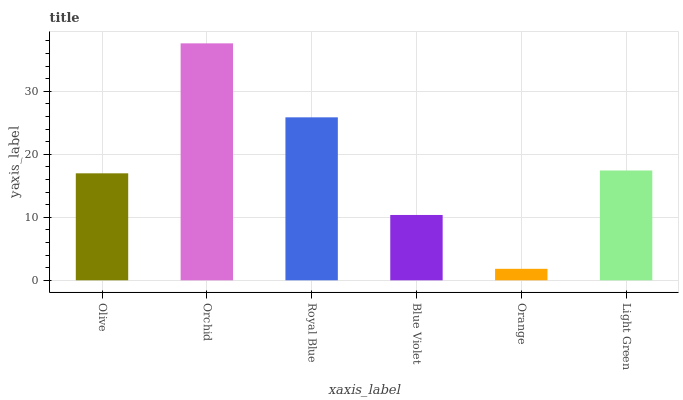Is Orange the minimum?
Answer yes or no. Yes. Is Orchid the maximum?
Answer yes or no. Yes. Is Royal Blue the minimum?
Answer yes or no. No. Is Royal Blue the maximum?
Answer yes or no. No. Is Orchid greater than Royal Blue?
Answer yes or no. Yes. Is Royal Blue less than Orchid?
Answer yes or no. Yes. Is Royal Blue greater than Orchid?
Answer yes or no. No. Is Orchid less than Royal Blue?
Answer yes or no. No. Is Light Green the high median?
Answer yes or no. Yes. Is Olive the low median?
Answer yes or no. Yes. Is Olive the high median?
Answer yes or no. No. Is Orchid the low median?
Answer yes or no. No. 